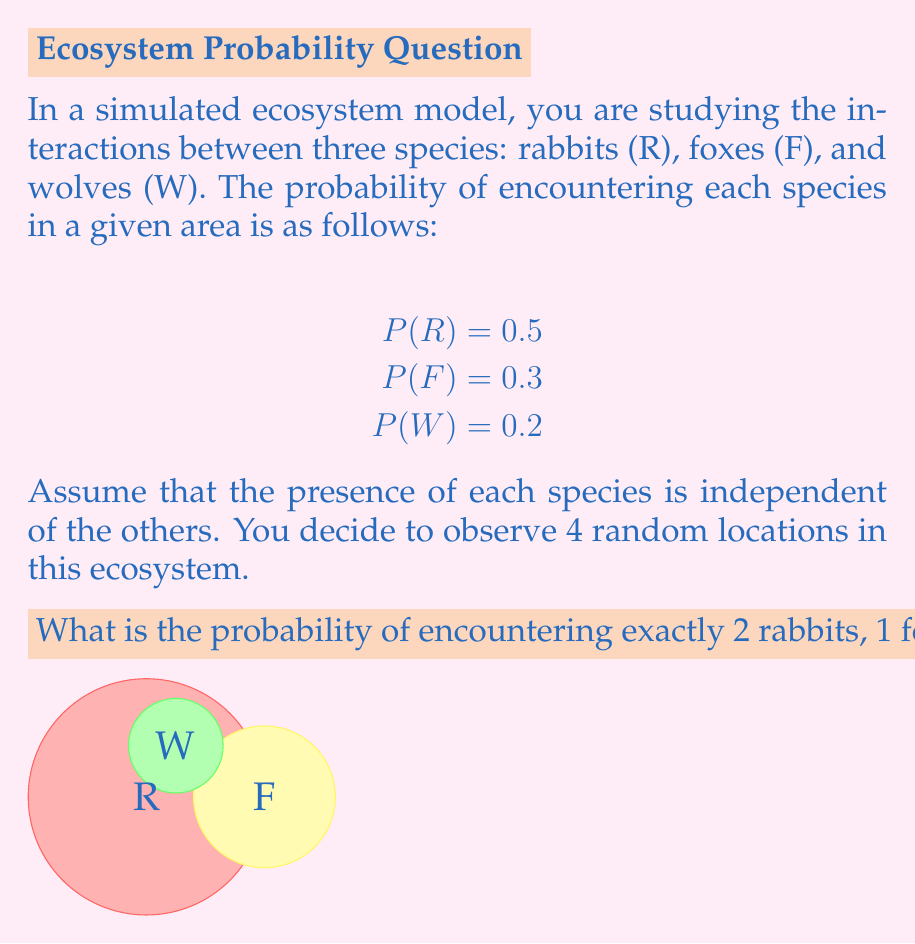What is the answer to this math problem? To solve this problem, we'll use the multinomial probability distribution, which is an extension of the binomial distribution for more than two outcomes. The steps are as follows:

1) First, recall the multinomial probability formula:
   $$P(X_1=x_1, X_2=x_2, ..., X_k=x_k) = \frac{n!}{x_1!x_2!...x_k!} p_1^{x_1} p_2^{x_2} ... p_k^{x_k}$$
   where $n$ is the total number of trials, $x_i$ is the number of occurrences of event $i$, and $p_i$ is the probability of event $i$.

2) In our case:
   $n = 4$ (total observations)
   $x_1 = 2$ (rabbits), $x_2 = 1$ (fox), $x_3 = 1$ (wolf)
   $p_1 = 0.5$ (rabbit probability), $p_2 = 0.3$ (fox probability), $p_3 = 0.2$ (wolf probability)

3) Plugging these values into the formula:
   $$P(R=2, F=1, W=1) = \frac{4!}{2!1!1!} (0.5)^2 (0.3)^1 (0.2)^1$$

4) Simplify:
   $$= \frac{24}{2} (0.25) (0.3) (0.2)$$
   $$= 12 \times 0.015$$
   $$= 0.18$$

Therefore, the probability of encountering exactly 2 rabbits, 1 fox, and 1 wolf in 4 random observations is 0.18 or 18%.
Answer: 0.18 